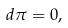Convert formula to latex. <formula><loc_0><loc_0><loc_500><loc_500>d \pi = 0 ,</formula> 